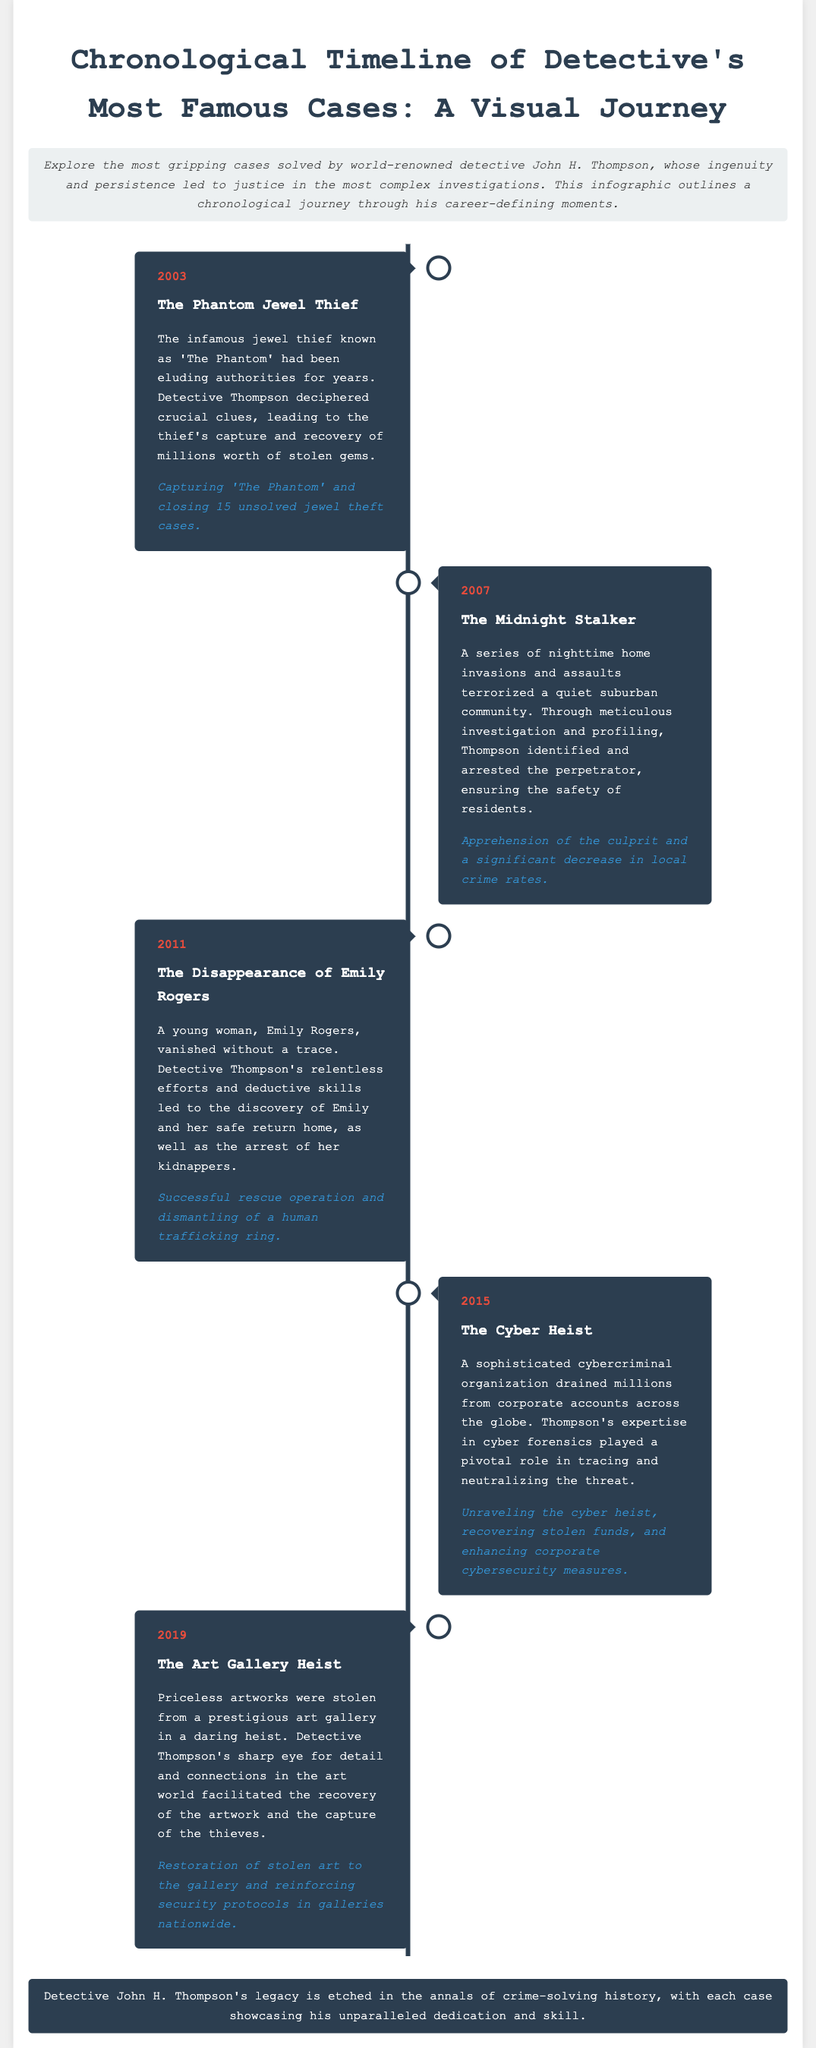What year did the case of The Phantom Jewel Thief occur? The document specifies that The Phantom Jewel Thief case took place in the year 2003.
Answer: 2003 Who is the detective featured in the timeline? The document identifies the detective as John H. Thompson.
Answer: John H. Thompson What was the key outcome of The Disappearance of Emily Rogers case? The key outcome mentioned for this case was the successful rescue operation and dismantling of a human trafficking ring.
Answer: Successful rescue operation In what year was The Cyber Heist case solved? The document indicates that The Cyber Heist case was solved in 2015.
Answer: 2015 How many cases are listed in the timeline? The document outlines a total of five famous cases in the timeline, from 2003 to 2019.
Answer: Five What was the main crime in The Midnight Stalker case? The document describes the main crime as nighttime home invasions and assaults.
Answer: Home invasions and assaults What role did Detective Thompson's expertise play in The Cyber Heist? The document states that his expertise in cyber forensics was pivotal in the investigation of The Cyber Heist.
Answer: Cyber forensics Which case involved capturing a thief known as 'The Phantom'? The document states that 'The Phantom' was captured during The Phantom Jewel Thief case.
Answer: The Phantom Jewel Thief What significant effect did the arrest in The Midnight Stalker case have on the community? The arrest led to a significant decrease in local crime rates, as mentioned in the document.
Answer: Decrease in local crime rates 